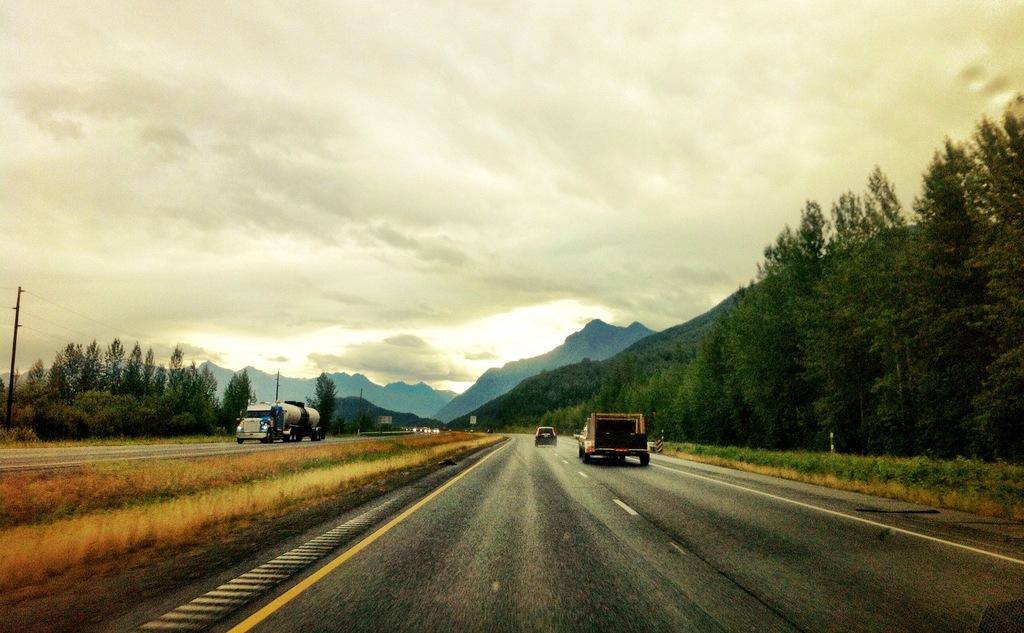What is the main feature of the image? There is a road in the image. What can be seen on both sides of the road? There are trees on either side of the road. What is visible in the background of the image? There is a mountain visible in the background of the image. Where is the zoo located in the image? There is no zoo present in the image. What type of quartz can be seen on the road in the image? There is no quartz present in the image. 